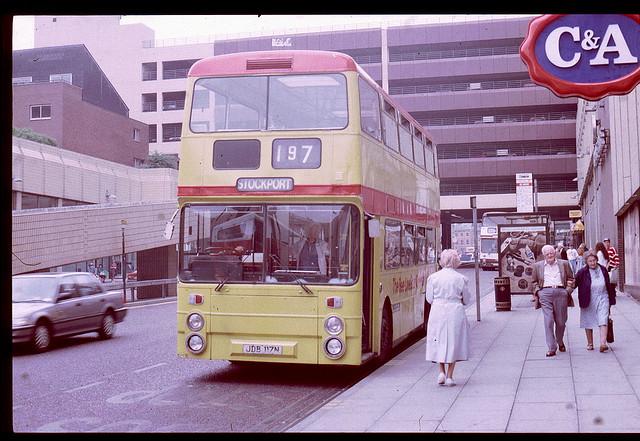What is the brand of bus?
Give a very brief answer. Stockport. Is the woman in the foreground young?
Write a very short answer. No. What does the sign say?
Answer briefly. C&a. Why would a double Decker bus be more convenient for people commuting?
Write a very short answer. More space. What are the two letters in the sign at top right?
Be succinct. Ca. 